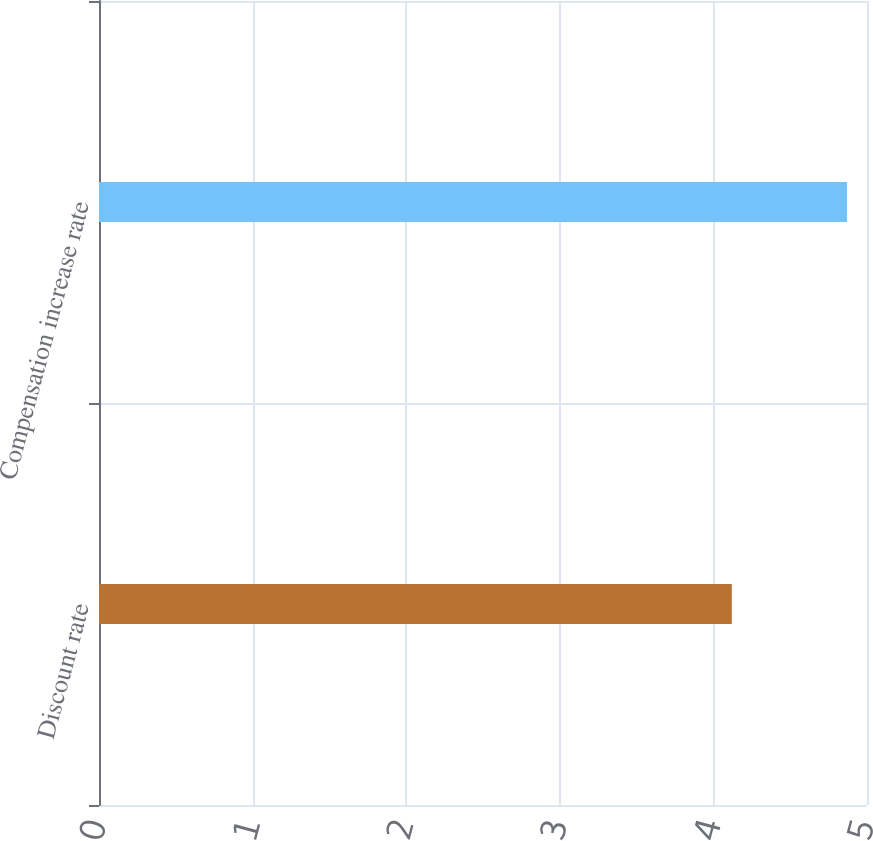Convert chart. <chart><loc_0><loc_0><loc_500><loc_500><bar_chart><fcel>Discount rate<fcel>Compensation increase rate<nl><fcel>4.12<fcel>4.87<nl></chart> 